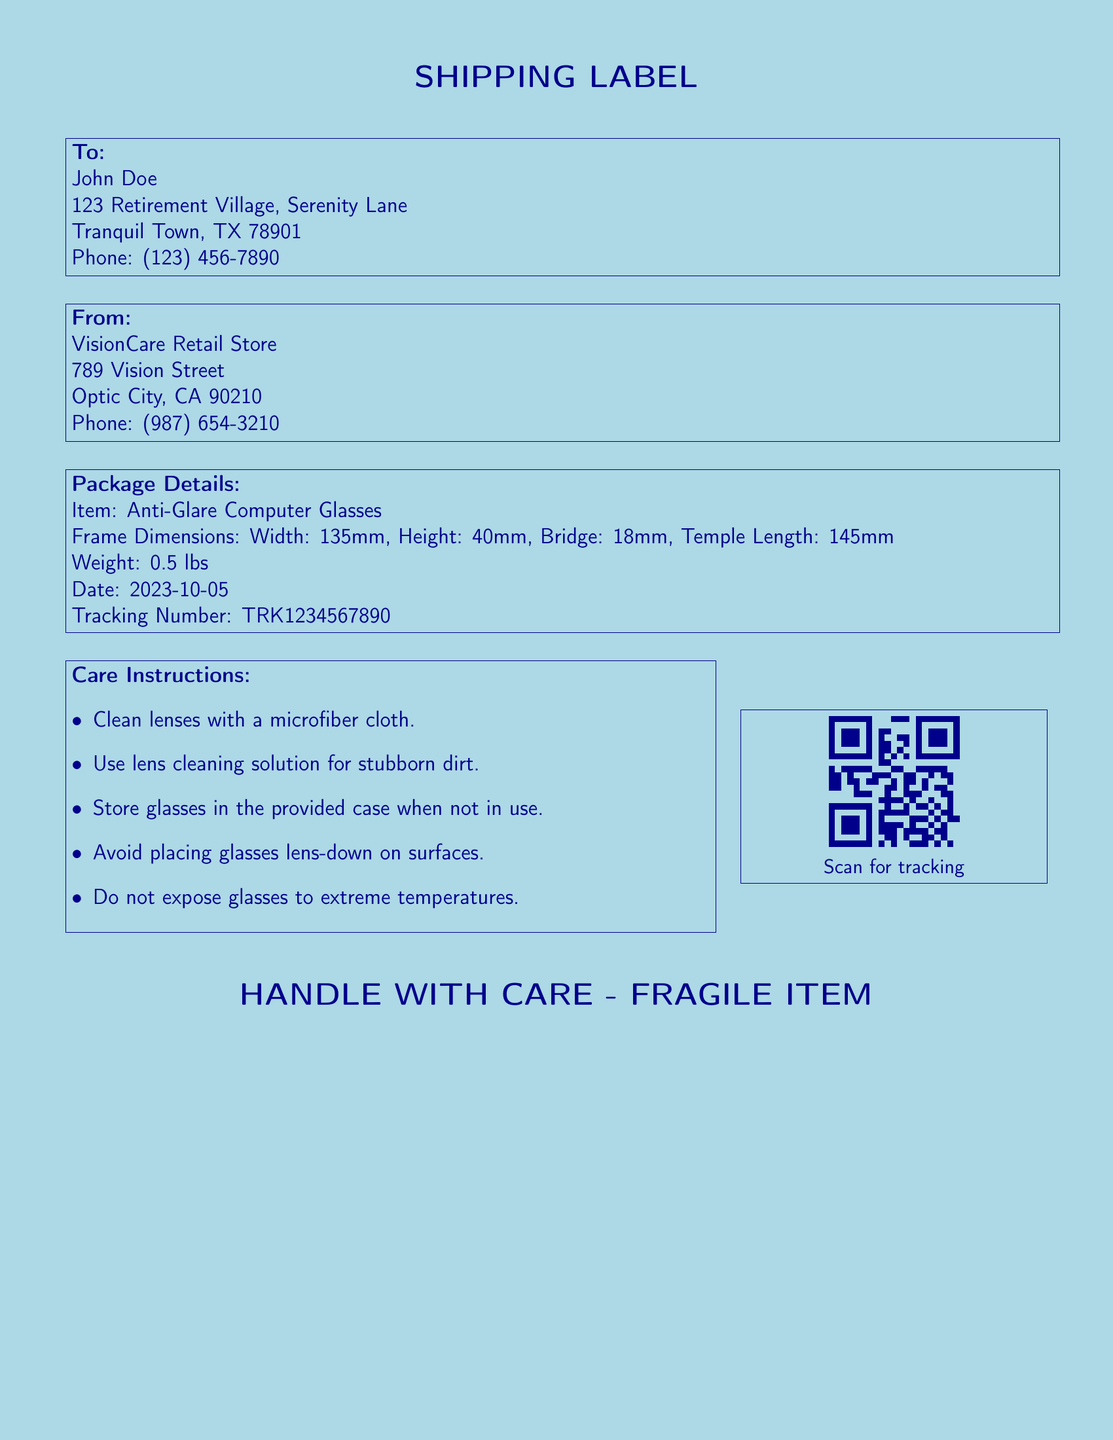What is the item being shipped? The item being shipped is listed in the package details section of the document.
Answer: Anti-Glare Computer Glasses What are the frame dimensions of the glasses? The frame dimensions are specified in the package details section.
Answer: Width: 135mm, Height: 40mm, Bridge: 18mm, Temple Length: 145mm What is the weight of the package? The weight of the package is provided in the package details section.
Answer: 0.5 lbs Who is the recipient? The recipient's name is listed in the "To:" section of the document.
Answer: John Doe What is the tracking number? The tracking number is provided in the package details section of the document.
Answer: TRK1234567890 What should you use to clean the lenses? The care instructions specify what to use for cleaning the lenses.
Answer: Microfiber cloth What should be done with the glasses when not in use? The care instructions mention storage recommendations for the glasses.
Answer: Store glasses in the provided case What warning is indicated on the label? The document includes a specific note regarding handling of the item.
Answer: HANDLE WITH CARE - FRAGILE ITEM 